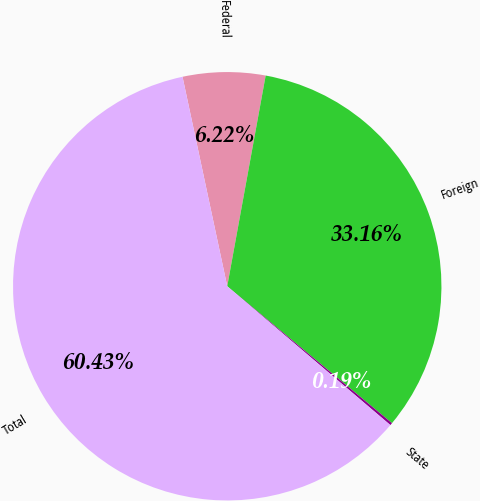Convert chart to OTSL. <chart><loc_0><loc_0><loc_500><loc_500><pie_chart><fcel>Federal<fcel>Foreign<fcel>State<fcel>Total<nl><fcel>6.22%<fcel>33.16%<fcel>0.19%<fcel>60.43%<nl></chart> 